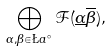<formula> <loc_0><loc_0><loc_500><loc_500>\bigoplus _ { \alpha , \beta \in \L a ^ { \, \circ } } \mathcal { F } ( \underline { \alpha } \overline { \beta } ) ,</formula> 